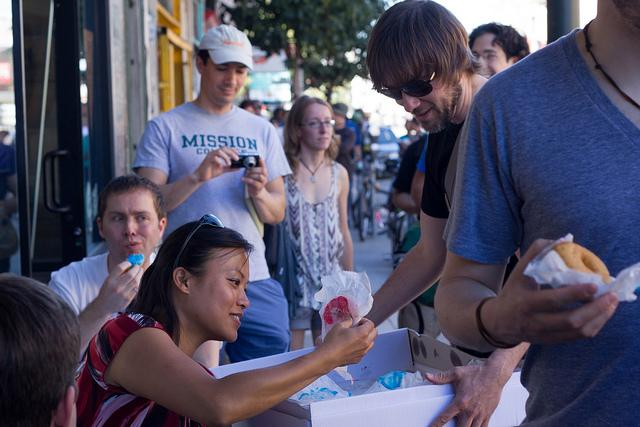What is the man wearing a hat doing with the camera? taking pictures 